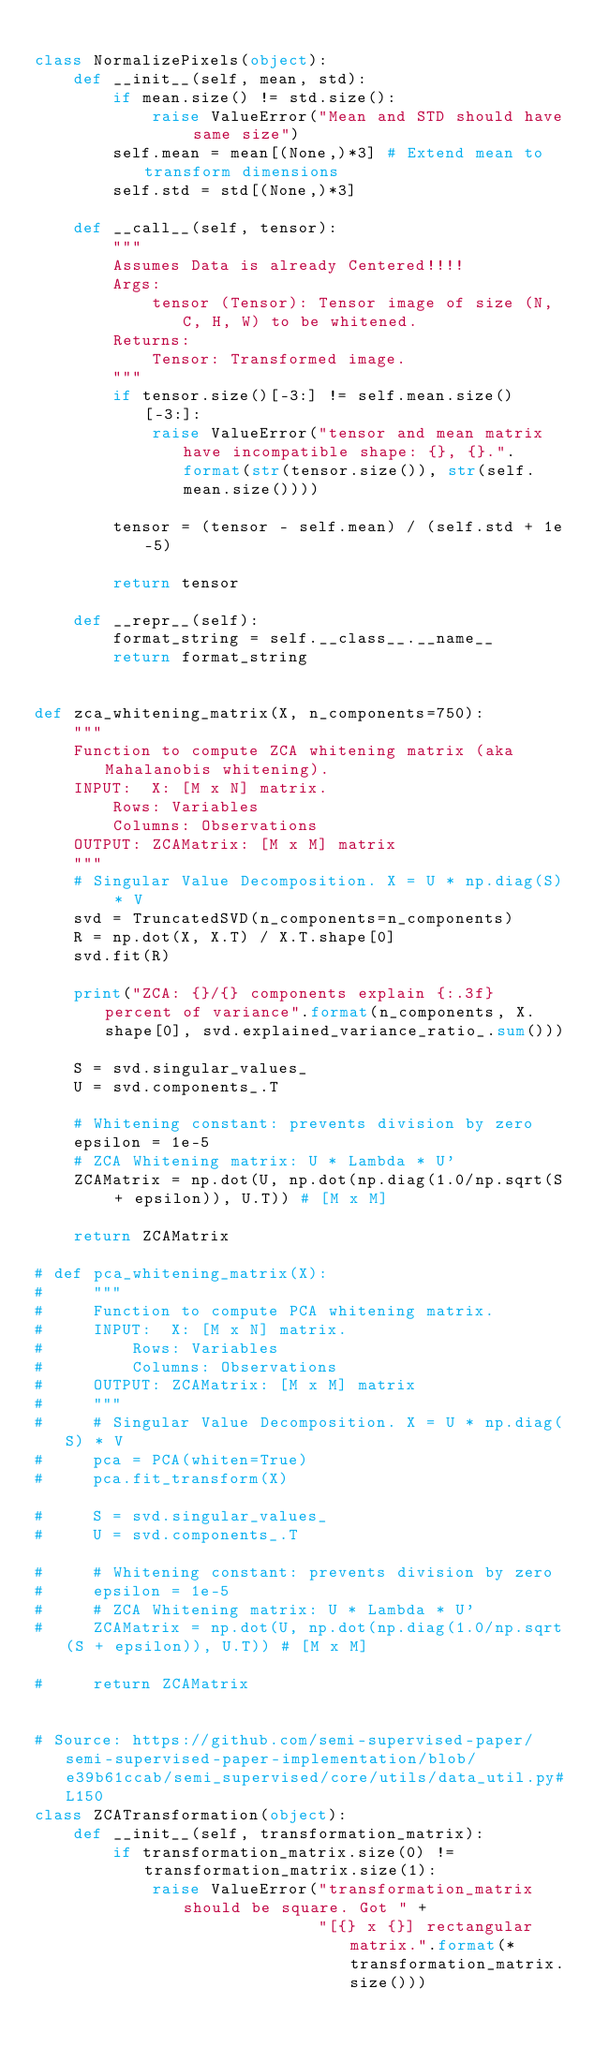Convert code to text. <code><loc_0><loc_0><loc_500><loc_500><_Python_>
class NormalizePixels(object):
    def __init__(self, mean, std):
        if mean.size() != std.size():
            raise ValueError("Mean and STD should have same size")
        self.mean = mean[(None,)*3] # Extend mean to transform dimensions
        self.std = std[(None,)*3]

    def __call__(self, tensor):
        """
        Assumes Data is already Centered!!!!
        Args:
            tensor (Tensor): Tensor image of size (N, C, H, W) to be whitened.
        Returns:
            Tensor: Transformed image.
        """
        if tensor.size()[-3:] != self.mean.size()[-3:]:
            raise ValueError("tensor and mean matrix have incompatible shape: {}, {}.".format(str(tensor.size()), str(self.mean.size())))

        tensor = (tensor - self.mean) / (self.std + 1e-5)

        return tensor

    def __repr__(self):
        format_string = self.__class__.__name__ 
        return format_string


def zca_whitening_matrix(X, n_components=750):
    """
    Function to compute ZCA whitening matrix (aka Mahalanobis whitening).
    INPUT:  X: [M x N] matrix.
        Rows: Variables
        Columns: Observations
    OUTPUT: ZCAMatrix: [M x M] matrix
    """
    # Singular Value Decomposition. X = U * np.diag(S) * V
    svd = TruncatedSVD(n_components=n_components)
    R = np.dot(X, X.T) / X.T.shape[0]
    svd.fit(R)

    print("ZCA: {}/{} components explain {:.3f} percent of variance".format(n_components, X.shape[0], svd.explained_variance_ratio_.sum()))

    S = svd.singular_values_
    U = svd.components_.T

    # Whitening constant: prevents division by zero
    epsilon = 1e-5
    # ZCA Whitening matrix: U * Lambda * U'
    ZCAMatrix = np.dot(U, np.dot(np.diag(1.0/np.sqrt(S + epsilon)), U.T)) # [M x M]

    return ZCAMatrix

# def pca_whitening_matrix(X):
#     """
#     Function to compute PCA whitening matrix.
#     INPUT:  X: [M x N] matrix.
#         Rows: Variables
#         Columns: Observations
#     OUTPUT: ZCAMatrix: [M x M] matrix
#     """
#     # Singular Value Decomposition. X = U * np.diag(S) * V
#     pca = PCA(whiten=True)
#     pca.fit_transform(X)

#     S = svd.singular_values_
#     U = svd.components_.T

#     # Whitening constant: prevents division by zero
#     epsilon = 1e-5
#     # ZCA Whitening matrix: U * Lambda * U'
#     ZCAMatrix = np.dot(U, np.dot(np.diag(1.0/np.sqrt(S + epsilon)), U.T)) # [M x M]

#     return ZCAMatrix


# Source: https://github.com/semi-supervised-paper/semi-supervised-paper-implementation/blob/e39b61ccab/semi_supervised/core/utils/data_util.py#L150
class ZCATransformation(object):
    def __init__(self, transformation_matrix):
        if transformation_matrix.size(0) != transformation_matrix.size(1):
            raise ValueError("transformation_matrix should be square. Got " +
                             "[{} x {}] rectangular matrix.".format(*transformation_matrix.size()))</code> 